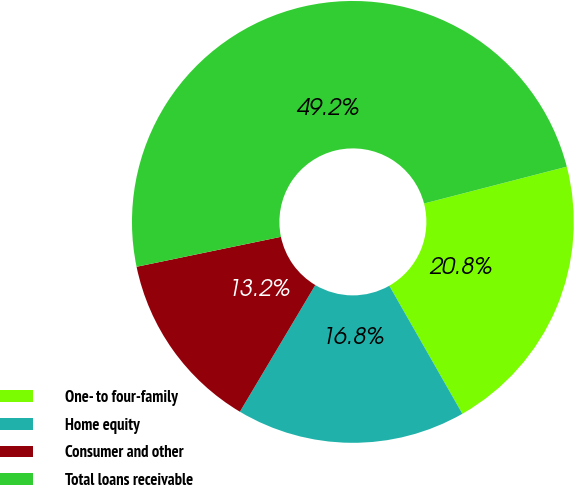Convert chart to OTSL. <chart><loc_0><loc_0><loc_500><loc_500><pie_chart><fcel>One- to four-family<fcel>Home equity<fcel>Consumer and other<fcel>Total loans receivable<nl><fcel>20.77%<fcel>16.8%<fcel>13.2%<fcel>49.24%<nl></chart> 